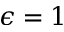Convert formula to latex. <formula><loc_0><loc_0><loc_500><loc_500>\epsilon = 1</formula> 